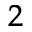<formula> <loc_0><loc_0><loc_500><loc_500>^ { 2 }</formula> 